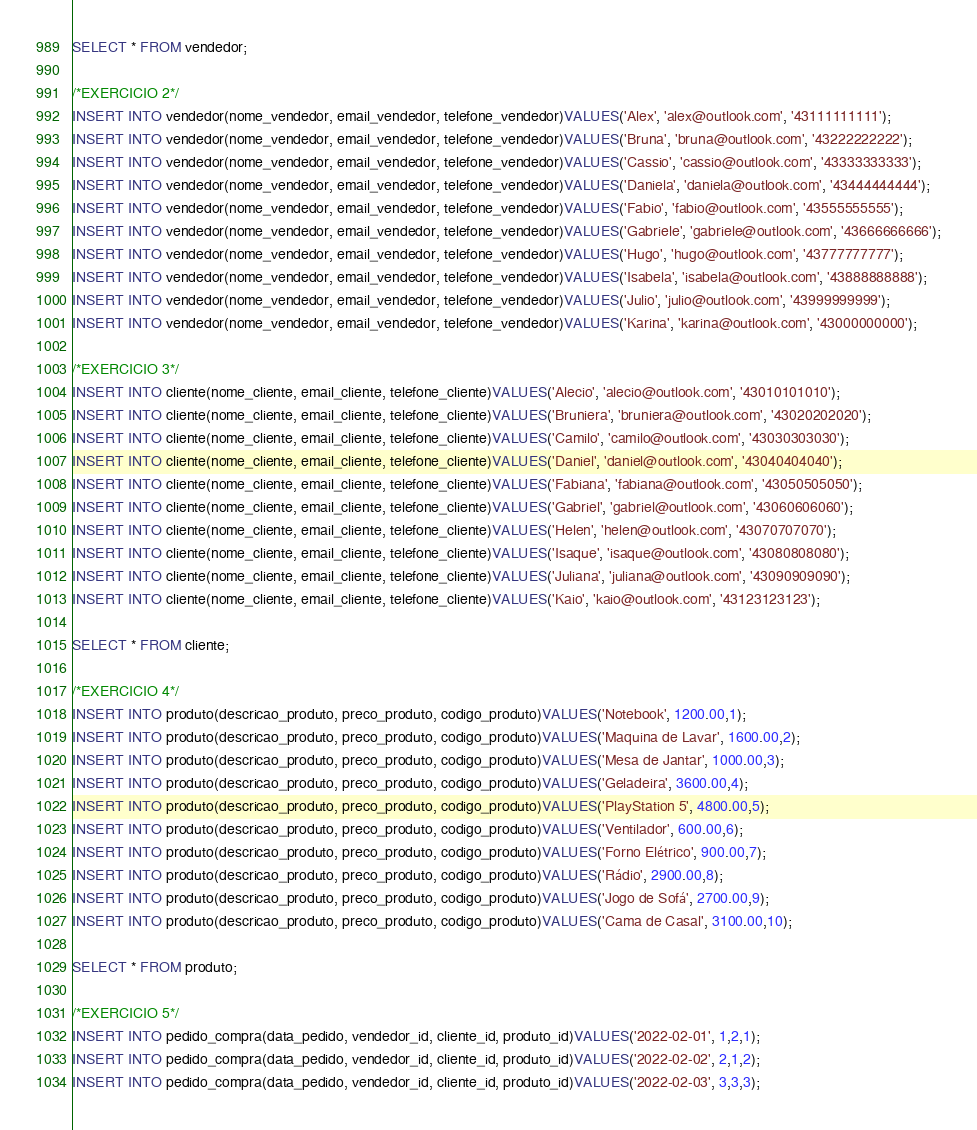<code> <loc_0><loc_0><loc_500><loc_500><_SQL_>SELECT * FROM vendedor;

/*EXERCICIO 2*/
INSERT INTO vendedor(nome_vendedor, email_vendedor, telefone_vendedor)VALUES('Alex', 'alex@outlook.com', '43111111111');
INSERT INTO vendedor(nome_vendedor, email_vendedor, telefone_vendedor)VALUES('Bruna', 'bruna@outlook.com', '43222222222');
INSERT INTO vendedor(nome_vendedor, email_vendedor, telefone_vendedor)VALUES('Cassio', 'cassio@outlook.com', '43333333333');
INSERT INTO vendedor(nome_vendedor, email_vendedor, telefone_vendedor)VALUES('Daniela', 'daniela@outlook.com', '43444444444');
INSERT INTO vendedor(nome_vendedor, email_vendedor, telefone_vendedor)VALUES('Fabio', 'fabio@outlook.com', '43555555555');
INSERT INTO vendedor(nome_vendedor, email_vendedor, telefone_vendedor)VALUES('Gabriele', 'gabriele@outlook.com', '43666666666');
INSERT INTO vendedor(nome_vendedor, email_vendedor, telefone_vendedor)VALUES('Hugo', 'hugo@outlook.com', '43777777777');
INSERT INTO vendedor(nome_vendedor, email_vendedor, telefone_vendedor)VALUES('Isabela', 'isabela@outlook.com', '43888888888');
INSERT INTO vendedor(nome_vendedor, email_vendedor, telefone_vendedor)VALUES('Julio', 'julio@outlook.com', '43999999999');
INSERT INTO vendedor(nome_vendedor, email_vendedor, telefone_vendedor)VALUES('Karina', 'karina@outlook.com', '43000000000');

/*EXERCICIO 3*/
INSERT INTO cliente(nome_cliente, email_cliente, telefone_cliente)VALUES('Alecio', 'alecio@outlook.com', '43010101010');
INSERT INTO cliente(nome_cliente, email_cliente, telefone_cliente)VALUES('Bruniera', 'bruniera@outlook.com', '43020202020');
INSERT INTO cliente(nome_cliente, email_cliente, telefone_cliente)VALUES('Camilo', 'camilo@outlook.com', '43030303030');
INSERT INTO cliente(nome_cliente, email_cliente, telefone_cliente)VALUES('Daniel', 'daniel@outlook.com', '43040404040');
INSERT INTO cliente(nome_cliente, email_cliente, telefone_cliente)VALUES('Fabiana', 'fabiana@outlook.com', '43050505050');
INSERT INTO cliente(nome_cliente, email_cliente, telefone_cliente)VALUES('Gabriel', 'gabriel@outlook.com', '43060606060');
INSERT INTO cliente(nome_cliente, email_cliente, telefone_cliente)VALUES('Helen', 'helen@outlook.com', '43070707070');
INSERT INTO cliente(nome_cliente, email_cliente, telefone_cliente)VALUES('Isaque', 'isaque@outlook.com', '43080808080');
INSERT INTO cliente(nome_cliente, email_cliente, telefone_cliente)VALUES('Juliana', 'juliana@outlook.com', '43090909090');
INSERT INTO cliente(nome_cliente, email_cliente, telefone_cliente)VALUES('Kaio', 'kaio@outlook.com', '43123123123');

SELECT * FROM cliente;

/*EXERCICIO 4*/
INSERT INTO produto(descricao_produto, preco_produto, codigo_produto)VALUES('Notebook', 1200.00,1);
INSERT INTO produto(descricao_produto, preco_produto, codigo_produto)VALUES('Maquina de Lavar', 1600.00,2);
INSERT INTO produto(descricao_produto, preco_produto, codigo_produto)VALUES('Mesa de Jantar', 1000.00,3);
INSERT INTO produto(descricao_produto, preco_produto, codigo_produto)VALUES('Geladeira', 3600.00,4);
INSERT INTO produto(descricao_produto, preco_produto, codigo_produto)VALUES('PlayStation 5', 4800.00,5);
INSERT INTO produto(descricao_produto, preco_produto, codigo_produto)VALUES('Ventilador', 600.00,6);
INSERT INTO produto(descricao_produto, preco_produto, codigo_produto)VALUES('Forno Elétrico', 900.00,7);
INSERT INTO produto(descricao_produto, preco_produto, codigo_produto)VALUES('Rádio', 2900.00,8);
INSERT INTO produto(descricao_produto, preco_produto, codigo_produto)VALUES('Jogo de Sofá', 2700.00,9);
INSERT INTO produto(descricao_produto, preco_produto, codigo_produto)VALUES('Cama de Casal', 3100.00,10);

SELECT * FROM produto;

/*EXERCICIO 5*/
INSERT INTO pedido_compra(data_pedido, vendedor_id, cliente_id, produto_id)VALUES('2022-02-01', 1,2,1);
INSERT INTO pedido_compra(data_pedido, vendedor_id, cliente_id, produto_id)VALUES('2022-02-02', 2,1,2);
INSERT INTO pedido_compra(data_pedido, vendedor_id, cliente_id, produto_id)VALUES('2022-02-03', 3,3,3);</code> 